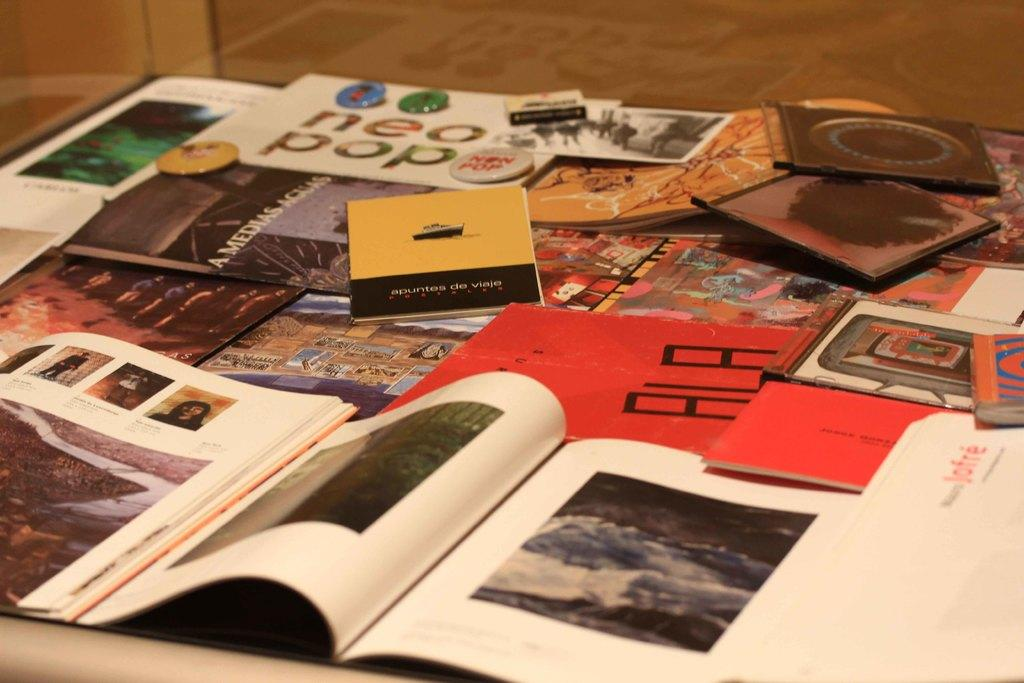<image>
Provide a brief description of the given image. A magazine that says Neo pop is on a table. 